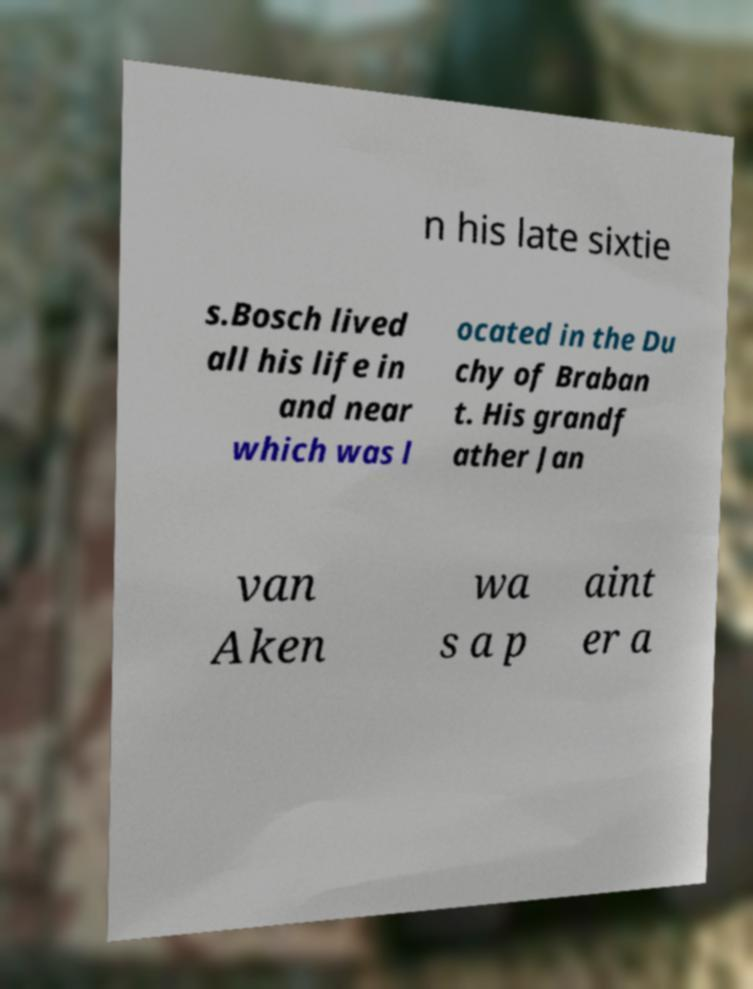Could you assist in decoding the text presented in this image and type it out clearly? n his late sixtie s.Bosch lived all his life in and near which was l ocated in the Du chy of Braban t. His grandf ather Jan van Aken wa s a p aint er a 